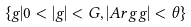<formula> <loc_0><loc_0><loc_500><loc_500>\{ g | 0 < | g | < G , | A r g g | < \theta \}</formula> 